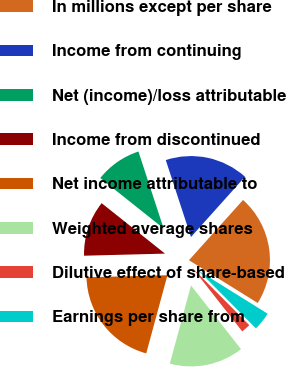Convert chart. <chart><loc_0><loc_0><loc_500><loc_500><pie_chart><fcel>In millions except per share<fcel>Income from continuing<fcel>Net (income)/loss attributable<fcel>Income from discontinued<fcel>Net income attributable to<fcel>Weighted average shares<fcel>Dilutive effect of share-based<fcel>Earnings per share from<nl><fcel>22.22%<fcel>16.67%<fcel>9.26%<fcel>11.11%<fcel>20.37%<fcel>14.81%<fcel>1.85%<fcel>3.7%<nl></chart> 